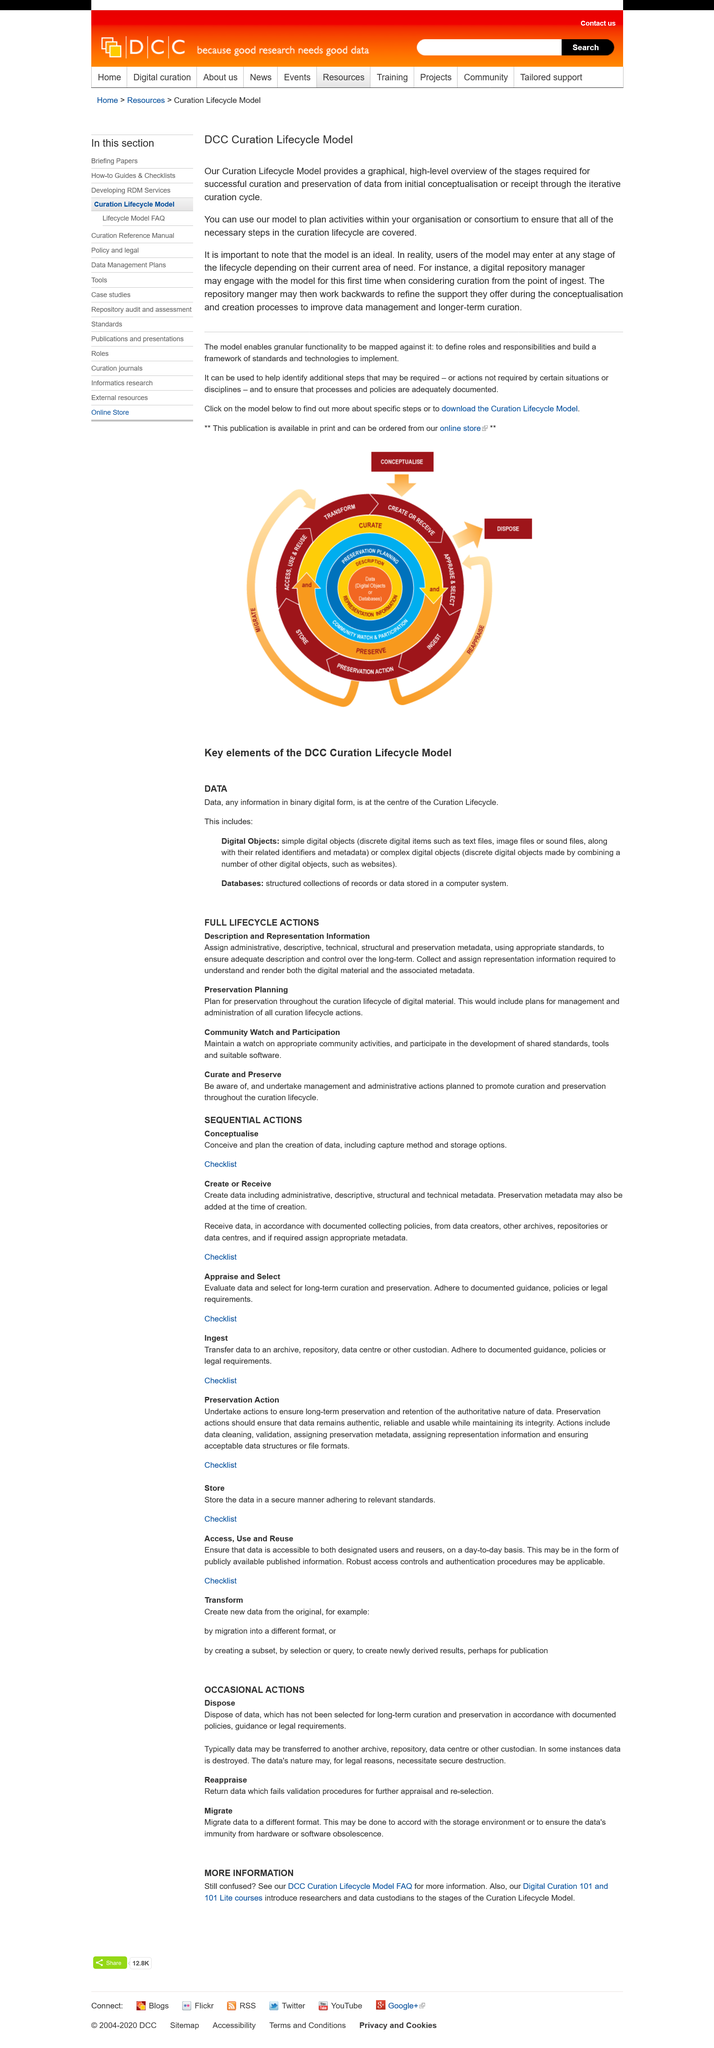List a handful of essential elements in this visual. When using the model to plan activities within your organization or consortium, it is important to note that the model is an ideal and not a one-size-fits-all solution. To ensure that all necessary steps in the curation lifecycle are covered, it is necessary to take into account the specific goals, resources, and limitations of your organization or consortium. The Curation Lifecycle Model provides a comprehensive, visual representation of the essential steps required for the successful curation and preservation of data, encompassing the initial stages of conceptualization or receipt through the ongoing iterative curation cycle. The users of the model have the option to enter at any stage of the lifecycle, depending on their current needs and requirements. 